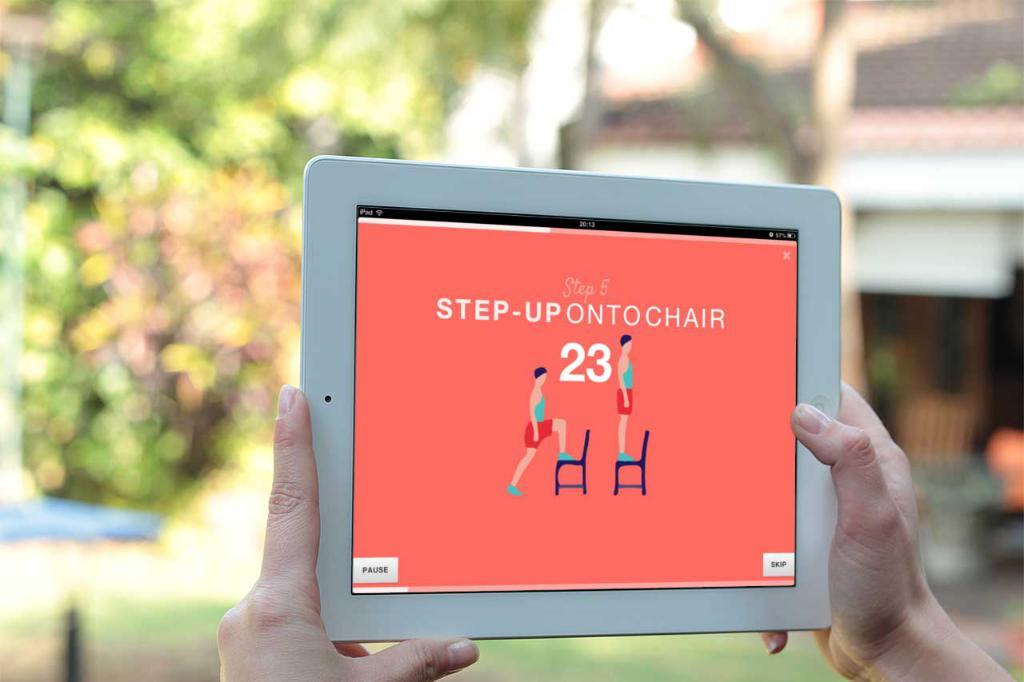What is the person in the image holding? The person is holding an iPad. What can be seen in the background of the image? There are trees and a building in the background of the image. How many children are playing on the amusement ride in the image? There are no children or amusement ride present in the image. What type of rose can be seen in the image? There is no rose present in the image. 